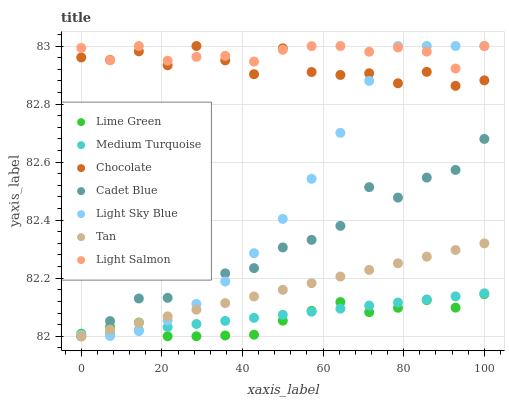Does Lime Green have the minimum area under the curve?
Answer yes or no. Yes. Does Light Salmon have the maximum area under the curve?
Answer yes or no. Yes. Does Cadet Blue have the minimum area under the curve?
Answer yes or no. No. Does Cadet Blue have the maximum area under the curve?
Answer yes or no. No. Is Medium Turquoise the smoothest?
Answer yes or no. Yes. Is Chocolate the roughest?
Answer yes or no. Yes. Is Cadet Blue the smoothest?
Answer yes or no. No. Is Cadet Blue the roughest?
Answer yes or no. No. Does Cadet Blue have the lowest value?
Answer yes or no. Yes. Does Chocolate have the lowest value?
Answer yes or no. No. Does Light Sky Blue have the highest value?
Answer yes or no. Yes. Does Cadet Blue have the highest value?
Answer yes or no. No. Is Lime Green less than Chocolate?
Answer yes or no. Yes. Is Light Salmon greater than Lime Green?
Answer yes or no. Yes. Does Lime Green intersect Medium Turquoise?
Answer yes or no. Yes. Is Lime Green less than Medium Turquoise?
Answer yes or no. No. Is Lime Green greater than Medium Turquoise?
Answer yes or no. No. Does Lime Green intersect Chocolate?
Answer yes or no. No. 